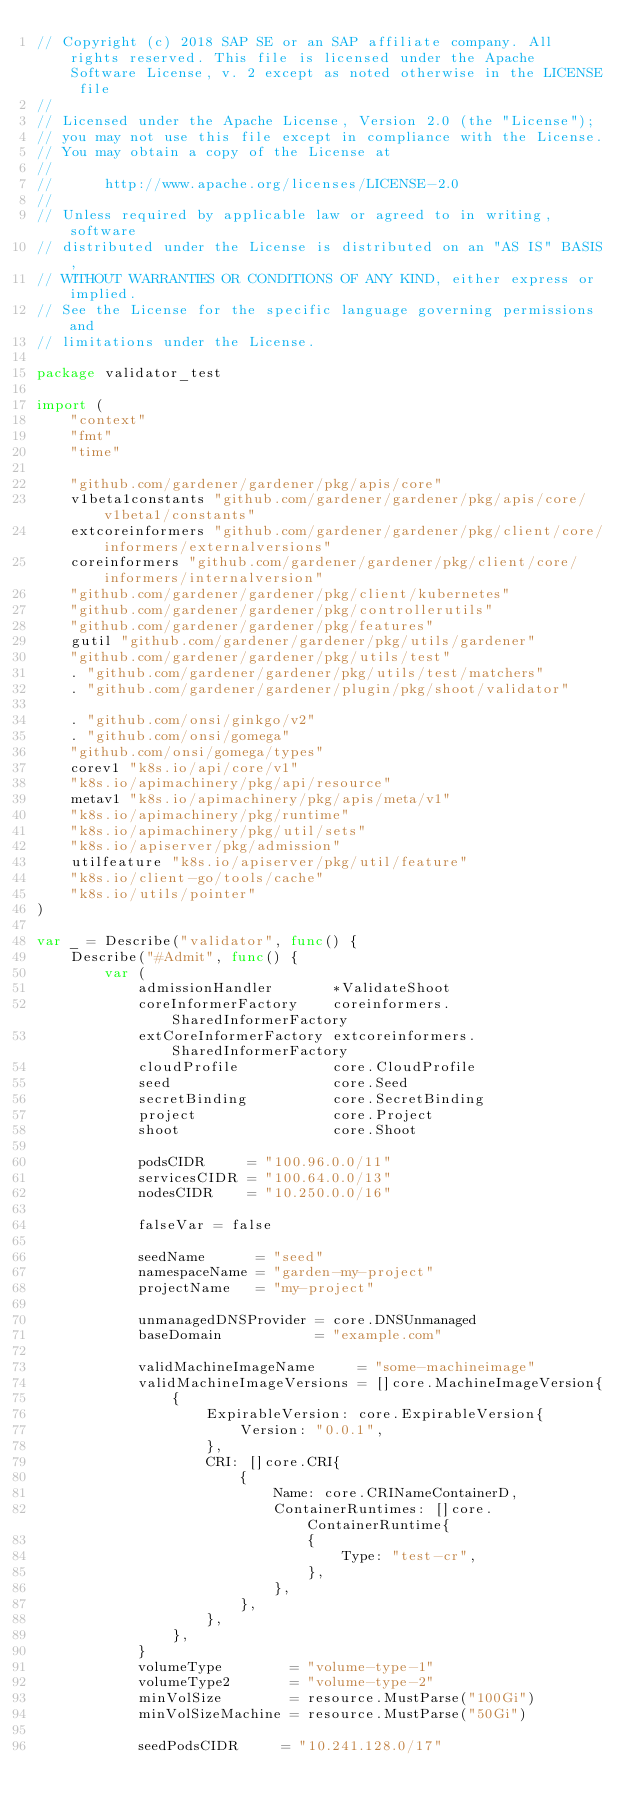<code> <loc_0><loc_0><loc_500><loc_500><_Go_>// Copyright (c) 2018 SAP SE or an SAP affiliate company. All rights reserved. This file is licensed under the Apache Software License, v. 2 except as noted otherwise in the LICENSE file
//
// Licensed under the Apache License, Version 2.0 (the "License");
// you may not use this file except in compliance with the License.
// You may obtain a copy of the License at
//
//      http://www.apache.org/licenses/LICENSE-2.0
//
// Unless required by applicable law or agreed to in writing, software
// distributed under the License is distributed on an "AS IS" BASIS,
// WITHOUT WARRANTIES OR CONDITIONS OF ANY KIND, either express or implied.
// See the License for the specific language governing permissions and
// limitations under the License.

package validator_test

import (
	"context"
	"fmt"
	"time"

	"github.com/gardener/gardener/pkg/apis/core"
	v1beta1constants "github.com/gardener/gardener/pkg/apis/core/v1beta1/constants"
	extcoreinformers "github.com/gardener/gardener/pkg/client/core/informers/externalversions"
	coreinformers "github.com/gardener/gardener/pkg/client/core/informers/internalversion"
	"github.com/gardener/gardener/pkg/client/kubernetes"
	"github.com/gardener/gardener/pkg/controllerutils"
	"github.com/gardener/gardener/pkg/features"
	gutil "github.com/gardener/gardener/pkg/utils/gardener"
	"github.com/gardener/gardener/pkg/utils/test"
	. "github.com/gardener/gardener/pkg/utils/test/matchers"
	. "github.com/gardener/gardener/plugin/pkg/shoot/validator"

	. "github.com/onsi/ginkgo/v2"
	. "github.com/onsi/gomega"
	"github.com/onsi/gomega/types"
	corev1 "k8s.io/api/core/v1"
	"k8s.io/apimachinery/pkg/api/resource"
	metav1 "k8s.io/apimachinery/pkg/apis/meta/v1"
	"k8s.io/apimachinery/pkg/runtime"
	"k8s.io/apimachinery/pkg/util/sets"
	"k8s.io/apiserver/pkg/admission"
	utilfeature "k8s.io/apiserver/pkg/util/feature"
	"k8s.io/client-go/tools/cache"
	"k8s.io/utils/pointer"
)

var _ = Describe("validator", func() {
	Describe("#Admit", func() {
		var (
			admissionHandler       *ValidateShoot
			coreInformerFactory    coreinformers.SharedInformerFactory
			extCoreInformerFactory extcoreinformers.SharedInformerFactory
			cloudProfile           core.CloudProfile
			seed                   core.Seed
			secretBinding          core.SecretBinding
			project                core.Project
			shoot                  core.Shoot

			podsCIDR     = "100.96.0.0/11"
			servicesCIDR = "100.64.0.0/13"
			nodesCIDR    = "10.250.0.0/16"

			falseVar = false

			seedName      = "seed"
			namespaceName = "garden-my-project"
			projectName   = "my-project"

			unmanagedDNSProvider = core.DNSUnmanaged
			baseDomain           = "example.com"

			validMachineImageName     = "some-machineimage"
			validMachineImageVersions = []core.MachineImageVersion{
				{
					ExpirableVersion: core.ExpirableVersion{
						Version: "0.0.1",
					},
					CRI: []core.CRI{
						{
							Name: core.CRINameContainerD,
							ContainerRuntimes: []core.ContainerRuntime{
								{
									Type: "test-cr",
								},
							},
						},
					},
				},
			}
			volumeType        = "volume-type-1"
			volumeType2       = "volume-type-2"
			minVolSize        = resource.MustParse("100Gi")
			minVolSizeMachine = resource.MustParse("50Gi")

			seedPodsCIDR     = "10.241.128.0/17"</code> 